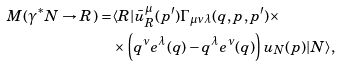Convert formula to latex. <formula><loc_0><loc_0><loc_500><loc_500>M ( \gamma ^ { * } N \to R ) = & \langle R | \bar { u } _ { R } ^ { \mu } ( p ^ { \prime } ) \Gamma _ { \mu \nu \lambda } ( q , p , p ^ { \prime } ) \times \\ & \times \left ( q ^ { \nu } e ^ { \lambda } ( q ) - q ^ { \lambda } e ^ { \nu } ( q ) \right ) u _ { N } ( p ) | N \rangle ,</formula> 